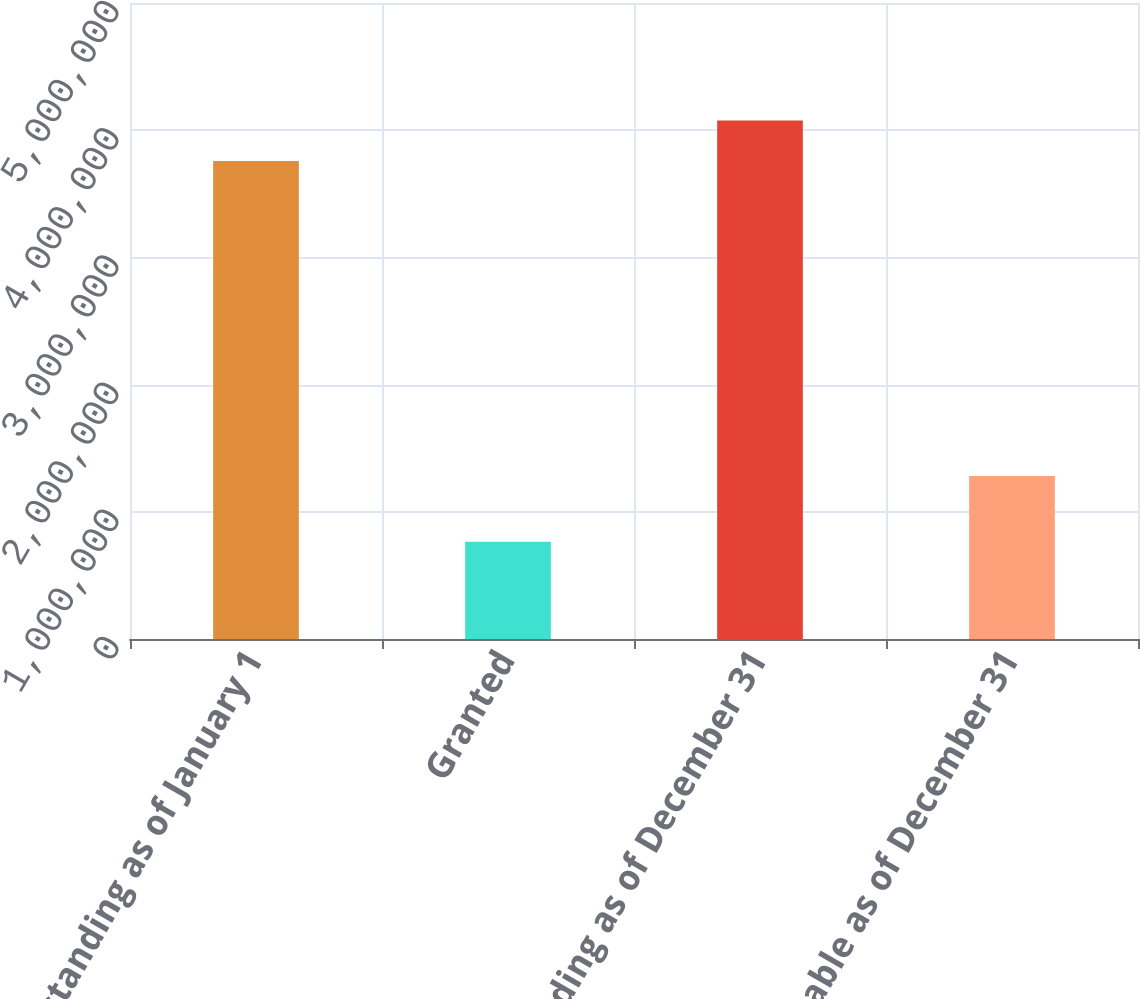Convert chart. <chart><loc_0><loc_0><loc_500><loc_500><bar_chart><fcel>Outstanding as of January 1<fcel>Granted<fcel>Outstanding as of December 31<fcel>Exercisable as of December 31<nl><fcel>3.75795e+06<fcel>764789<fcel>4.07636e+06<fcel>1.2805e+06<nl></chart> 